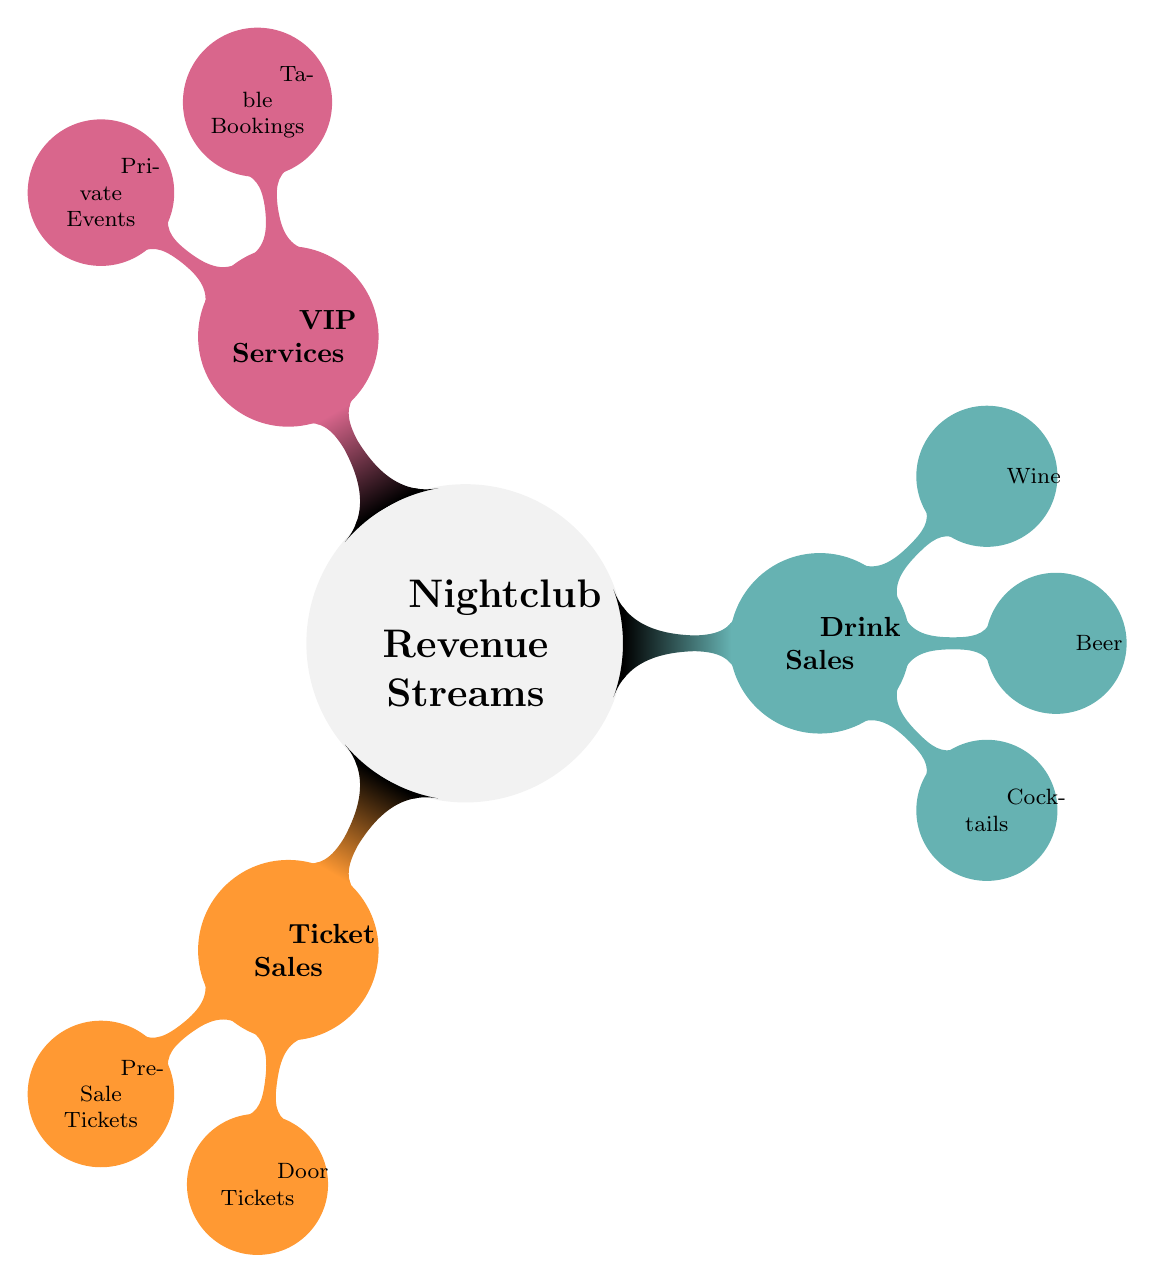What are the three main sources of income for the nightclub? The diagram lists three main sources of income under "Nightclub Revenue Streams": Ticket Sales, Drink Sales, and VIP Services.
Answer: Ticket Sales, Drink Sales, VIP Services How many types of ticket sales are specified in the diagram? Under "Ticket Sales," there are two specific types mentioned: Pre-Sale Tickets and Door Tickets. Therefore, the count is two.
Answer: 2 Which type of sales is associated with Table Bookings? Table Bookings fall under the category of VIP Services as shown in the diagram, indicating that they are a source of revenue from premium offerings.
Answer: VIP Services What types of drinks are included in the drink sales category? The diagram lists three types of drinks under Drink Sales: Cocktails, Beer, and Wine. Therefore, the specific items mentioned are three.
Answer: Cocktails, Beer, Wine If a nightclub wants to increase its income stream, which area could it emphasize based on the diagram? The diagram shows three distinct income areas; if the nightclub aims to enhance revenue, focusing on expanding VIP Services could be beneficial since they typically offer higher margins than regular drink sales or ticket sales.
Answer: VIP Services How many children nodes are there under the Drink Sales category? The diagram shows three specific child nodes under Drink Sales: Cocktails, Beer, and Wine, resulting in a total of three child nodes.
Answer: 3 Which category includes Private Events in the diagram? Private Events is specified as a child node under the VIP Services category in the diagram, indicating that it is a source of income within that segment.
Answer: VIP Services What is the primary focus area for revenue streams in the nightclub as presented in the diagram? The primary focus area is represented by the three main categories: Ticket Sales, Drink Sales, and VIP Services, collectively highlighting the diverse income sources of the nightclub.
Answer: Nightclub Revenue Streams 